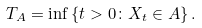<formula> <loc_0><loc_0><loc_500><loc_500>T _ { A } = \inf \left \{ t > 0 \colon X _ { t } \in A \right \} .</formula> 